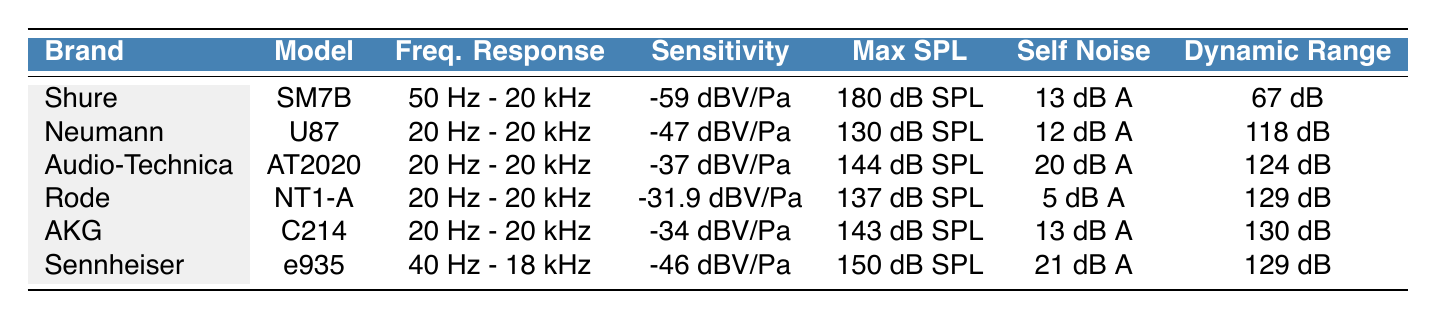What is the frequency response of the Rode NT1-A? The table lists the frequency response for each brand and model. For the Rode NT1-A, the corresponding value in the table is "20 Hz - 20 kHz."
Answer: 20 Hz - 20 kHz Which microphone has the highest sensitivity? To find the microphone with the highest sensitivity, we review the sensitivity values in the table. The highest value is "-31.9 dBV/Pa" for the Rode NT1-A.
Answer: Rode NT1-A What is the dynamic range of the Neumann U87? The table shows the dynamic range for each microphone. For the Neumann U87, the value listed is "118 dB."
Answer: 118 dB Is the max sound pressure level of the Shure SM7B greater than 150 dB SPL? The table indicates that the max sound pressure level for the Shure SM7B is "180 dB SPL." Since 180 is greater than 150, the answer is yes.
Answer: Yes Which microphone has the least self-noise? The self-noise values listed in the table must be compared. The Rode NT1-A has the lowest self-noise value of "5 dB A-weighted."
Answer: Rode NT1-A Calculate the average dynamic range of all microphones listed. To find the average dynamic range, we add up the dynamic ranges for all microphones: 67 + 118 + 124 + 129 + 130 + 129 = 797. There are 6 microphones, so the average is 797 / 6 = approximately 132.83.
Answer: 132.83 Does the Audio-Technica AT2020 have a max sound pressure level below 150 dB SPL? The table states that the max sound pressure level for the Audio-Technica AT2020 is "144 dB SPL." Since 144 is below 150, the answer is yes.
Answer: Yes What is the self-noise difference between the Shure SM7B and the Sennheiser e935? The self-noise for Shure SM7B is "13 dB A-weighted" and for Sennheiser e935 is "21 dB A-weighted." The difference is 21 - 13 = 8 dB, indicating the Sennheiser has 8 dB more self-noise.
Answer: 8 dB Identify the microphone with both the widest frequency response and the highest dynamic range. Analyzing the table, the Neumann U87 and Audio-Technica AT2020 both have a frequency response of "20 Hz - 20 kHz." The AT2020 has a higher dynamic range of "124 dB" compared to U87's "118 dB." Therefore, the Audio-Technica AT2020 is the answer.
Answer: Audio-Technica AT2020 